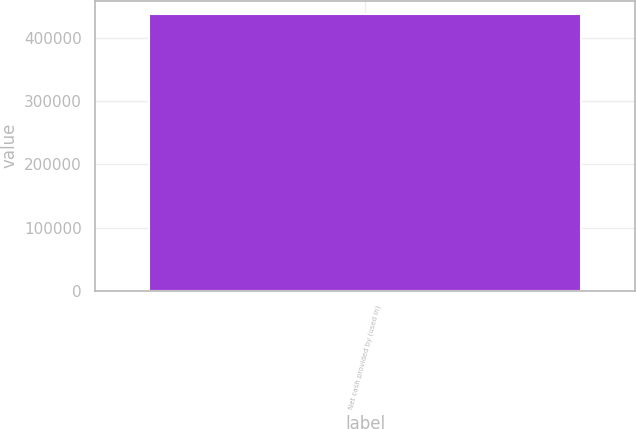Convert chart to OTSL. <chart><loc_0><loc_0><loc_500><loc_500><bar_chart><fcel>Net cash provided by (used in)<nl><fcel>436843<nl></chart> 